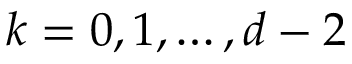Convert formula to latex. <formula><loc_0><loc_0><loc_500><loc_500>k = 0 , 1 , \dots , d - 2</formula> 